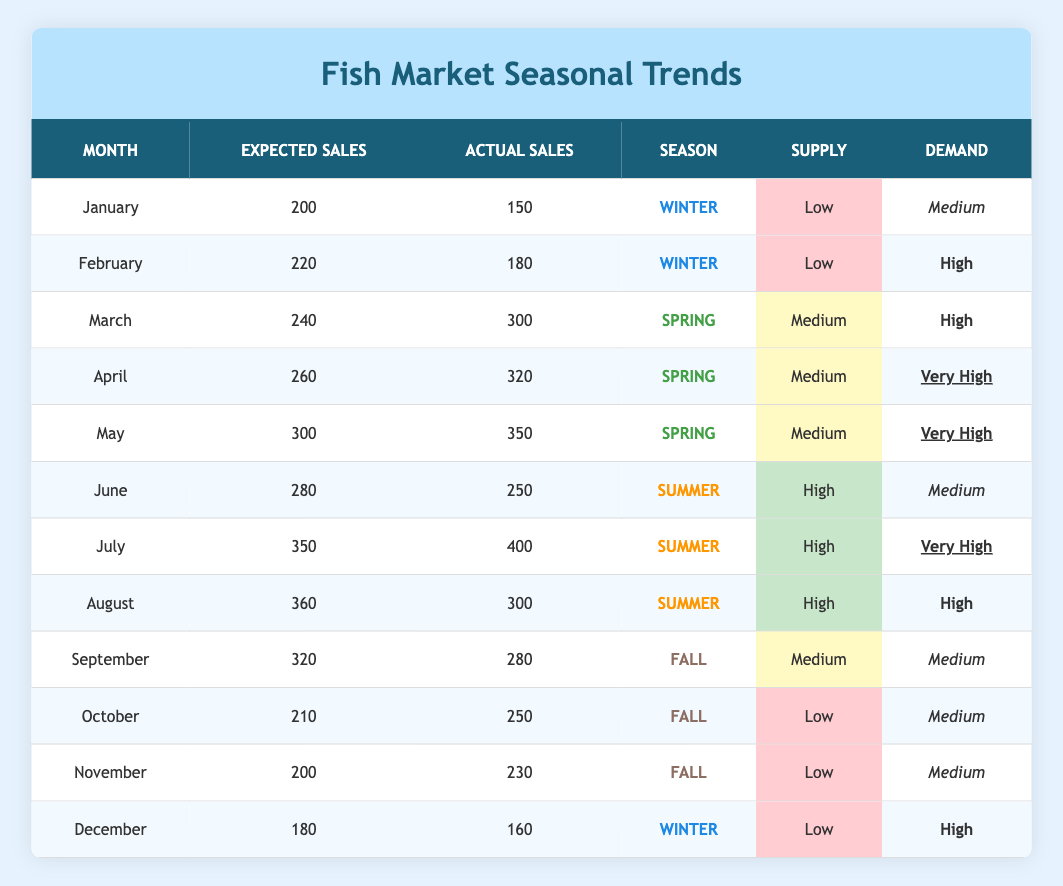What were the actual sales in February? The table shows the actual sales for February as 180.
Answer: 180 How many months have actual sales exceeding expected sales? By reviewing each month, actual sales exceed expected sales in March, April, May, July, October, and November, totaling 6 months.
Answer: 6 What is the total expected sales for the Spring season? Adding the expected sales for March (240), April (260), and May (300), we get 240 + 260 + 300 = 800.
Answer: 800 Is the supply low for all months in Winter? The supply for January, February, and December is low, confirming that supply is low for all winter months.
Answer: Yes What was the difference between actual sales and expected sales in July? To find the difference, subtract the expected sales (350) from the actual sales (400), which gives us 400 - 350 = 50.
Answer: 50 In which month did actual sales fall below expected sales but the demand was high? In December, actual sales were 160 while expected sales were 180, and demand was high.
Answer: December What is the average actual sales across all months? Calculate the total actual sales: (150 + 180 + 300 + 320 + 350 + 250 + 400 + 300 + 280 + 250 + 230 + 160) = 2870, and then divide by the number of months (12) to get 2870 / 12 ≈ 239.17. Therefore, rounding down we consider 239.
Answer: 239 How many months showed high demand? The months with high demand are February, March, April, July, and August, totaling 5 months with high demand.
Answer: 5 Which season had the highest average of actual sales? Calculate the average for each season: Winter (total 490 / 3 = 163.33), Spring (total 930 / 3 = 310), Summer (total 950 / 3 ≈ 316.67), Fall (total 498 / 3 = 166). Summer has the highest average with approximately 316.67.
Answer: Summer What were the actual sales in June compared to expected sales for that month? Actual sales in June were 250, while expected sales were 280, thus falling short by 30.
Answer: 30 short 